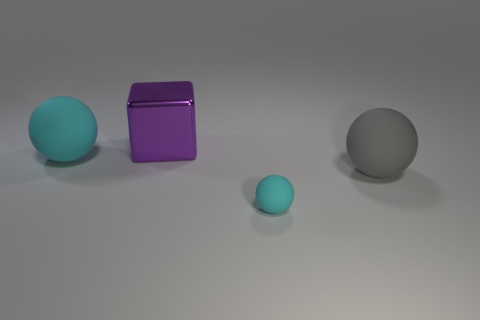Subtract all large cyan rubber balls. How many balls are left? 2 Subtract all balls. How many objects are left? 1 Subtract all yellow blocks. How many cyan balls are left? 2 Add 1 big gray rubber balls. How many objects exist? 5 Subtract all gray balls. How many balls are left? 2 Add 2 spheres. How many spheres are left? 5 Add 2 large shiny blocks. How many large shiny blocks exist? 3 Subtract 0 yellow cylinders. How many objects are left? 4 Subtract all red balls. Subtract all cyan cubes. How many balls are left? 3 Subtract all purple shiny blocks. Subtract all large gray balls. How many objects are left? 2 